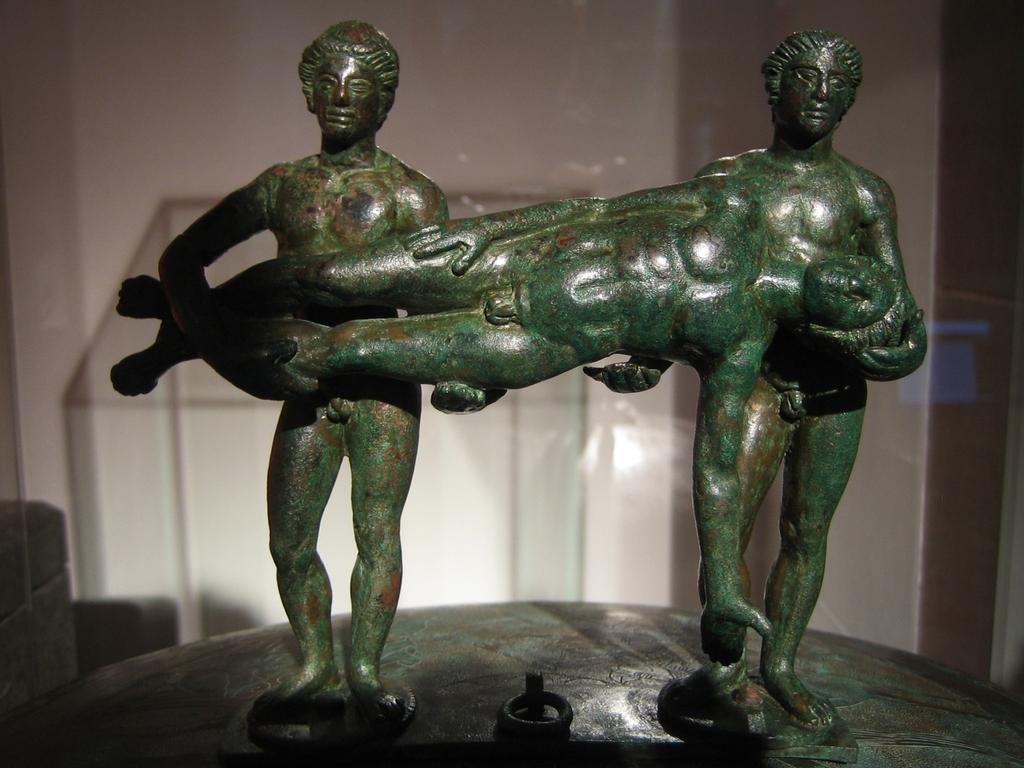How would you summarize this image in a sentence or two? In this picture we can see sculptures on a pedestal. In the background it seems like a glass and we can see the wall. 